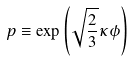<formula> <loc_0><loc_0><loc_500><loc_500>p \equiv \exp \left ( \sqrt { \frac { 2 } { 3 } } \kappa \phi \right )</formula> 